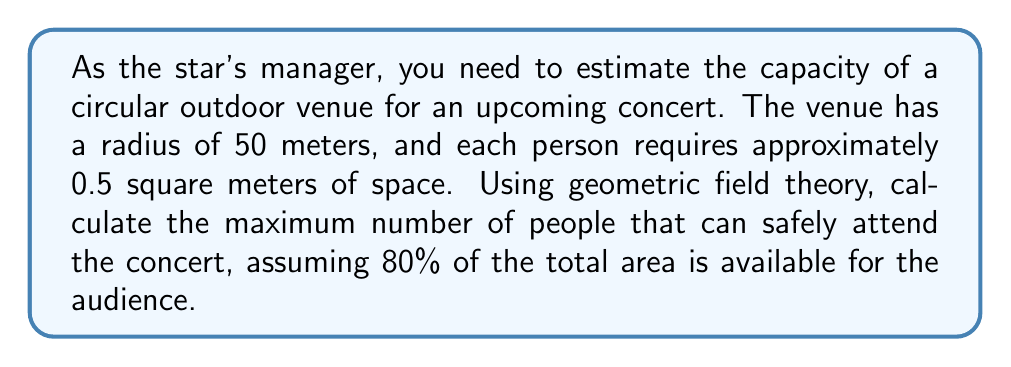Teach me how to tackle this problem. Let's approach this step-by-step using geometric field theory concepts:

1) First, we need to calculate the total area of the circular venue:
   $$A_{total} = \pi r^2$$
   $$A_{total} = \pi (50\text{ m})^2 = 7,853.98\text{ m}^2$$

2) Now, we consider that only 80% of this area is available for the audience:
   $$A_{available} = 0.80 \times A_{total}$$
   $$A_{available} = 0.80 \times 7,853.98\text{ m}^2 = 6,283.18\text{ m}^2$$

3) Each person requires 0.5 square meters of space. To find the number of people that can fit, we divide the available area by the space required per person:
   $$N_{people} = \frac{A_{available}}{A_{per person}}$$
   $$N_{people} = \frac{6,283.18\text{ m}^2}{0.5\text{ m}^2/person} = 12,566.36\text{ people}$$

4) Since we can't have a fractional number of people, we round down to the nearest whole number:
   $$N_{people} = 12,566\text{ people}$$

This approach uses the concept of area in a circular field and applies it to a real-world scenario, demonstrating the practical application of geometric field theory in event planning and crowd management.
Answer: 12,566 people 